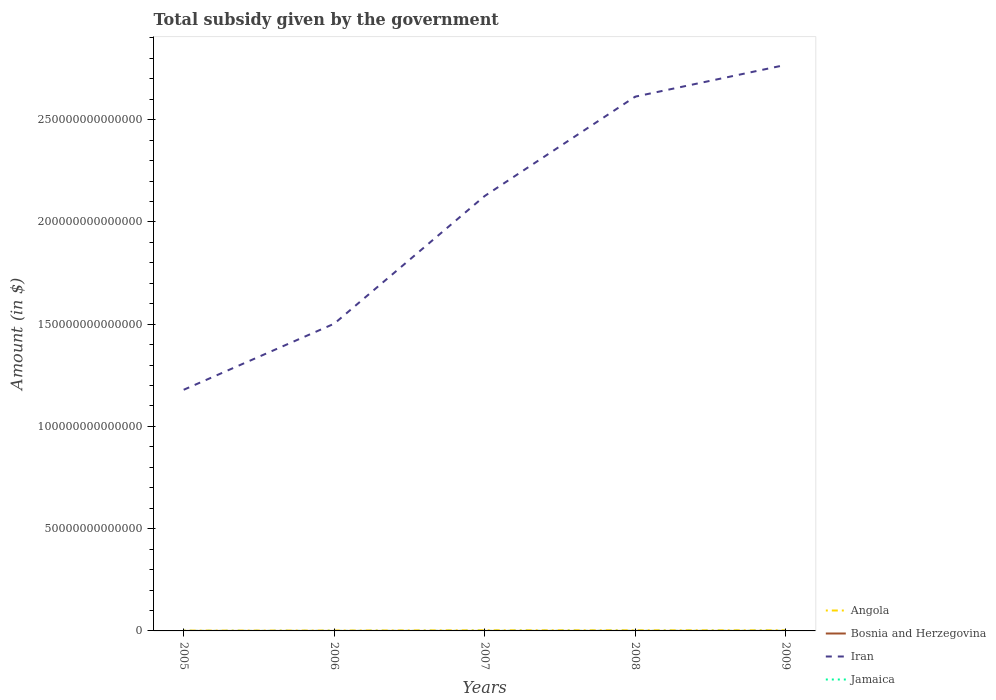Across all years, what is the maximum total revenue collected by the government in Bosnia and Herzegovina?
Your answer should be very brief. 2.42e+09. In which year was the total revenue collected by the government in Iran maximum?
Offer a very short reply. 2005. What is the total total revenue collected by the government in Bosnia and Herzegovina in the graph?
Ensure brevity in your answer.  -1.09e+09. What is the difference between the highest and the second highest total revenue collected by the government in Bosnia and Herzegovina?
Your response must be concise. 1.95e+09. What is the difference between two consecutive major ticks on the Y-axis?
Keep it short and to the point. 5.00e+13. Does the graph contain any zero values?
Give a very brief answer. No. Where does the legend appear in the graph?
Provide a short and direct response. Bottom right. How many legend labels are there?
Keep it short and to the point. 4. How are the legend labels stacked?
Your response must be concise. Vertical. What is the title of the graph?
Offer a terse response. Total subsidy given by the government. Does "Peru" appear as one of the legend labels in the graph?
Offer a very short reply. No. What is the label or title of the Y-axis?
Keep it short and to the point. Amount (in $). What is the Amount (in $) in Angola in 2005?
Your answer should be compact. 1.53e+11. What is the Amount (in $) of Bosnia and Herzegovina in 2005?
Ensure brevity in your answer.  2.42e+09. What is the Amount (in $) in Iran in 2005?
Keep it short and to the point. 1.18e+14. What is the Amount (in $) of Jamaica in 2005?
Offer a very short reply. 1.32e+1. What is the Amount (in $) of Angola in 2006?
Keep it short and to the point. 1.86e+11. What is the Amount (in $) in Bosnia and Herzegovina in 2006?
Make the answer very short. 2.77e+09. What is the Amount (in $) of Iran in 2006?
Provide a short and direct response. 1.50e+14. What is the Amount (in $) of Jamaica in 2006?
Your answer should be very brief. 1.67e+1. What is the Amount (in $) of Angola in 2007?
Your response must be concise. 2.96e+11. What is the Amount (in $) of Bosnia and Herzegovina in 2007?
Provide a succinct answer. 3.51e+09. What is the Amount (in $) in Iran in 2007?
Provide a short and direct response. 2.13e+14. What is the Amount (in $) in Jamaica in 2007?
Your response must be concise. 2.02e+1. What is the Amount (in $) of Angola in 2008?
Your response must be concise. 2.94e+11. What is the Amount (in $) of Bosnia and Herzegovina in 2008?
Your answer should be compact. 4.37e+09. What is the Amount (in $) in Iran in 2008?
Your answer should be very brief. 2.61e+14. What is the Amount (in $) of Jamaica in 2008?
Your response must be concise. 2.37e+1. What is the Amount (in $) in Angola in 2009?
Your response must be concise. 2.86e+11. What is the Amount (in $) of Bosnia and Herzegovina in 2009?
Your answer should be very brief. 4.37e+09. What is the Amount (in $) of Iran in 2009?
Make the answer very short. 2.77e+14. What is the Amount (in $) of Jamaica in 2009?
Keep it short and to the point. 2.53e+1. Across all years, what is the maximum Amount (in $) in Angola?
Ensure brevity in your answer.  2.96e+11. Across all years, what is the maximum Amount (in $) in Bosnia and Herzegovina?
Your answer should be very brief. 4.37e+09. Across all years, what is the maximum Amount (in $) in Iran?
Your answer should be very brief. 2.77e+14. Across all years, what is the maximum Amount (in $) in Jamaica?
Provide a short and direct response. 2.53e+1. Across all years, what is the minimum Amount (in $) of Angola?
Your answer should be very brief. 1.53e+11. Across all years, what is the minimum Amount (in $) of Bosnia and Herzegovina?
Ensure brevity in your answer.  2.42e+09. Across all years, what is the minimum Amount (in $) of Iran?
Provide a succinct answer. 1.18e+14. Across all years, what is the minimum Amount (in $) of Jamaica?
Your answer should be compact. 1.32e+1. What is the total Amount (in $) in Angola in the graph?
Ensure brevity in your answer.  1.21e+12. What is the total Amount (in $) in Bosnia and Herzegovina in the graph?
Ensure brevity in your answer.  1.74e+1. What is the total Amount (in $) of Iran in the graph?
Give a very brief answer. 1.02e+15. What is the total Amount (in $) of Jamaica in the graph?
Ensure brevity in your answer.  9.90e+1. What is the difference between the Amount (in $) of Angola in 2005 and that in 2006?
Offer a terse response. -3.26e+1. What is the difference between the Amount (in $) of Bosnia and Herzegovina in 2005 and that in 2006?
Offer a very short reply. -3.45e+08. What is the difference between the Amount (in $) of Iran in 2005 and that in 2006?
Offer a very short reply. -3.23e+13. What is the difference between the Amount (in $) in Jamaica in 2005 and that in 2006?
Offer a terse response. -3.44e+09. What is the difference between the Amount (in $) in Angola in 2005 and that in 2007?
Offer a very short reply. -1.43e+11. What is the difference between the Amount (in $) in Bosnia and Herzegovina in 2005 and that in 2007?
Provide a short and direct response. -1.09e+09. What is the difference between the Amount (in $) of Iran in 2005 and that in 2007?
Make the answer very short. -9.48e+13. What is the difference between the Amount (in $) in Jamaica in 2005 and that in 2007?
Ensure brevity in your answer.  -6.96e+09. What is the difference between the Amount (in $) of Angola in 2005 and that in 2008?
Ensure brevity in your answer.  -1.41e+11. What is the difference between the Amount (in $) in Bosnia and Herzegovina in 2005 and that in 2008?
Your answer should be very brief. -1.95e+09. What is the difference between the Amount (in $) of Iran in 2005 and that in 2008?
Provide a short and direct response. -1.43e+14. What is the difference between the Amount (in $) in Jamaica in 2005 and that in 2008?
Offer a terse response. -1.05e+1. What is the difference between the Amount (in $) in Angola in 2005 and that in 2009?
Your answer should be compact. -1.33e+11. What is the difference between the Amount (in $) of Bosnia and Herzegovina in 2005 and that in 2009?
Keep it short and to the point. -1.95e+09. What is the difference between the Amount (in $) in Iran in 2005 and that in 2009?
Your answer should be very brief. -1.59e+14. What is the difference between the Amount (in $) of Jamaica in 2005 and that in 2009?
Your answer should be very brief. -1.20e+1. What is the difference between the Amount (in $) in Angola in 2006 and that in 2007?
Make the answer very short. -1.11e+11. What is the difference between the Amount (in $) of Bosnia and Herzegovina in 2006 and that in 2007?
Give a very brief answer. -7.43e+08. What is the difference between the Amount (in $) of Iran in 2006 and that in 2007?
Make the answer very short. -6.24e+13. What is the difference between the Amount (in $) in Jamaica in 2006 and that in 2007?
Your answer should be compact. -3.52e+09. What is the difference between the Amount (in $) of Angola in 2006 and that in 2008?
Offer a terse response. -1.08e+11. What is the difference between the Amount (in $) of Bosnia and Herzegovina in 2006 and that in 2008?
Your answer should be compact. -1.60e+09. What is the difference between the Amount (in $) in Iran in 2006 and that in 2008?
Make the answer very short. -1.11e+14. What is the difference between the Amount (in $) of Jamaica in 2006 and that in 2008?
Your answer should be very brief. -7.02e+09. What is the difference between the Amount (in $) in Angola in 2006 and that in 2009?
Provide a succinct answer. -1.00e+11. What is the difference between the Amount (in $) of Bosnia and Herzegovina in 2006 and that in 2009?
Ensure brevity in your answer.  -1.60e+09. What is the difference between the Amount (in $) in Iran in 2006 and that in 2009?
Your answer should be compact. -1.27e+14. What is the difference between the Amount (in $) of Jamaica in 2006 and that in 2009?
Your answer should be very brief. -8.60e+09. What is the difference between the Amount (in $) of Angola in 2007 and that in 2008?
Your answer should be compact. 2.50e+09. What is the difference between the Amount (in $) of Bosnia and Herzegovina in 2007 and that in 2008?
Provide a short and direct response. -8.58e+08. What is the difference between the Amount (in $) in Iran in 2007 and that in 2008?
Provide a short and direct response. -4.86e+13. What is the difference between the Amount (in $) in Jamaica in 2007 and that in 2008?
Provide a short and direct response. -3.50e+09. What is the difference between the Amount (in $) of Angola in 2007 and that in 2009?
Offer a very short reply. 1.06e+1. What is the difference between the Amount (in $) in Bosnia and Herzegovina in 2007 and that in 2009?
Give a very brief answer. -8.59e+08. What is the difference between the Amount (in $) of Iran in 2007 and that in 2009?
Offer a very short reply. -6.41e+13. What is the difference between the Amount (in $) of Jamaica in 2007 and that in 2009?
Offer a terse response. -5.08e+09. What is the difference between the Amount (in $) of Angola in 2008 and that in 2009?
Provide a succinct answer. 8.11e+09. What is the difference between the Amount (in $) of Bosnia and Herzegovina in 2008 and that in 2009?
Make the answer very short. -8.19e+05. What is the difference between the Amount (in $) in Iran in 2008 and that in 2009?
Give a very brief answer. -1.55e+13. What is the difference between the Amount (in $) of Jamaica in 2008 and that in 2009?
Ensure brevity in your answer.  -1.58e+09. What is the difference between the Amount (in $) of Angola in 2005 and the Amount (in $) of Bosnia and Herzegovina in 2006?
Provide a succinct answer. 1.50e+11. What is the difference between the Amount (in $) of Angola in 2005 and the Amount (in $) of Iran in 2006?
Offer a very short reply. -1.50e+14. What is the difference between the Amount (in $) of Angola in 2005 and the Amount (in $) of Jamaica in 2006?
Ensure brevity in your answer.  1.36e+11. What is the difference between the Amount (in $) of Bosnia and Herzegovina in 2005 and the Amount (in $) of Iran in 2006?
Provide a short and direct response. -1.50e+14. What is the difference between the Amount (in $) in Bosnia and Herzegovina in 2005 and the Amount (in $) in Jamaica in 2006?
Make the answer very short. -1.42e+1. What is the difference between the Amount (in $) in Iran in 2005 and the Amount (in $) in Jamaica in 2006?
Your response must be concise. 1.18e+14. What is the difference between the Amount (in $) of Angola in 2005 and the Amount (in $) of Bosnia and Herzegovina in 2007?
Your response must be concise. 1.49e+11. What is the difference between the Amount (in $) in Angola in 2005 and the Amount (in $) in Iran in 2007?
Offer a very short reply. -2.13e+14. What is the difference between the Amount (in $) in Angola in 2005 and the Amount (in $) in Jamaica in 2007?
Provide a short and direct response. 1.33e+11. What is the difference between the Amount (in $) of Bosnia and Herzegovina in 2005 and the Amount (in $) of Iran in 2007?
Offer a very short reply. -2.13e+14. What is the difference between the Amount (in $) in Bosnia and Herzegovina in 2005 and the Amount (in $) in Jamaica in 2007?
Ensure brevity in your answer.  -1.78e+1. What is the difference between the Amount (in $) in Iran in 2005 and the Amount (in $) in Jamaica in 2007?
Your answer should be very brief. 1.18e+14. What is the difference between the Amount (in $) of Angola in 2005 and the Amount (in $) of Bosnia and Herzegovina in 2008?
Your answer should be compact. 1.49e+11. What is the difference between the Amount (in $) in Angola in 2005 and the Amount (in $) in Iran in 2008?
Keep it short and to the point. -2.61e+14. What is the difference between the Amount (in $) in Angola in 2005 and the Amount (in $) in Jamaica in 2008?
Provide a short and direct response. 1.29e+11. What is the difference between the Amount (in $) in Bosnia and Herzegovina in 2005 and the Amount (in $) in Iran in 2008?
Make the answer very short. -2.61e+14. What is the difference between the Amount (in $) of Bosnia and Herzegovina in 2005 and the Amount (in $) of Jamaica in 2008?
Provide a short and direct response. -2.13e+1. What is the difference between the Amount (in $) of Iran in 2005 and the Amount (in $) of Jamaica in 2008?
Your answer should be compact. 1.18e+14. What is the difference between the Amount (in $) of Angola in 2005 and the Amount (in $) of Bosnia and Herzegovina in 2009?
Keep it short and to the point. 1.49e+11. What is the difference between the Amount (in $) of Angola in 2005 and the Amount (in $) of Iran in 2009?
Keep it short and to the point. -2.77e+14. What is the difference between the Amount (in $) in Angola in 2005 and the Amount (in $) in Jamaica in 2009?
Ensure brevity in your answer.  1.28e+11. What is the difference between the Amount (in $) in Bosnia and Herzegovina in 2005 and the Amount (in $) in Iran in 2009?
Make the answer very short. -2.77e+14. What is the difference between the Amount (in $) of Bosnia and Herzegovina in 2005 and the Amount (in $) of Jamaica in 2009?
Your answer should be very brief. -2.28e+1. What is the difference between the Amount (in $) of Iran in 2005 and the Amount (in $) of Jamaica in 2009?
Offer a terse response. 1.18e+14. What is the difference between the Amount (in $) of Angola in 2006 and the Amount (in $) of Bosnia and Herzegovina in 2007?
Provide a short and direct response. 1.82e+11. What is the difference between the Amount (in $) in Angola in 2006 and the Amount (in $) in Iran in 2007?
Give a very brief answer. -2.12e+14. What is the difference between the Amount (in $) of Angola in 2006 and the Amount (in $) of Jamaica in 2007?
Offer a terse response. 1.65e+11. What is the difference between the Amount (in $) of Bosnia and Herzegovina in 2006 and the Amount (in $) of Iran in 2007?
Your answer should be very brief. -2.13e+14. What is the difference between the Amount (in $) in Bosnia and Herzegovina in 2006 and the Amount (in $) in Jamaica in 2007?
Your response must be concise. -1.74e+1. What is the difference between the Amount (in $) of Iran in 2006 and the Amount (in $) of Jamaica in 2007?
Your response must be concise. 1.50e+14. What is the difference between the Amount (in $) in Angola in 2006 and the Amount (in $) in Bosnia and Herzegovina in 2008?
Give a very brief answer. 1.81e+11. What is the difference between the Amount (in $) in Angola in 2006 and the Amount (in $) in Iran in 2008?
Offer a very short reply. -2.61e+14. What is the difference between the Amount (in $) in Angola in 2006 and the Amount (in $) in Jamaica in 2008?
Offer a very short reply. 1.62e+11. What is the difference between the Amount (in $) in Bosnia and Herzegovina in 2006 and the Amount (in $) in Iran in 2008?
Provide a short and direct response. -2.61e+14. What is the difference between the Amount (in $) in Bosnia and Herzegovina in 2006 and the Amount (in $) in Jamaica in 2008?
Ensure brevity in your answer.  -2.09e+1. What is the difference between the Amount (in $) of Iran in 2006 and the Amount (in $) of Jamaica in 2008?
Provide a succinct answer. 1.50e+14. What is the difference between the Amount (in $) in Angola in 2006 and the Amount (in $) in Bosnia and Herzegovina in 2009?
Give a very brief answer. 1.81e+11. What is the difference between the Amount (in $) of Angola in 2006 and the Amount (in $) of Iran in 2009?
Offer a terse response. -2.77e+14. What is the difference between the Amount (in $) of Angola in 2006 and the Amount (in $) of Jamaica in 2009?
Provide a short and direct response. 1.60e+11. What is the difference between the Amount (in $) of Bosnia and Herzegovina in 2006 and the Amount (in $) of Iran in 2009?
Make the answer very short. -2.77e+14. What is the difference between the Amount (in $) of Bosnia and Herzegovina in 2006 and the Amount (in $) of Jamaica in 2009?
Provide a short and direct response. -2.25e+1. What is the difference between the Amount (in $) of Iran in 2006 and the Amount (in $) of Jamaica in 2009?
Your answer should be very brief. 1.50e+14. What is the difference between the Amount (in $) in Angola in 2007 and the Amount (in $) in Bosnia and Herzegovina in 2008?
Offer a very short reply. 2.92e+11. What is the difference between the Amount (in $) of Angola in 2007 and the Amount (in $) of Iran in 2008?
Give a very brief answer. -2.61e+14. What is the difference between the Amount (in $) of Angola in 2007 and the Amount (in $) of Jamaica in 2008?
Provide a succinct answer. 2.73e+11. What is the difference between the Amount (in $) of Bosnia and Herzegovina in 2007 and the Amount (in $) of Iran in 2008?
Your answer should be compact. -2.61e+14. What is the difference between the Amount (in $) of Bosnia and Herzegovina in 2007 and the Amount (in $) of Jamaica in 2008?
Ensure brevity in your answer.  -2.02e+1. What is the difference between the Amount (in $) in Iran in 2007 and the Amount (in $) in Jamaica in 2008?
Make the answer very short. 2.13e+14. What is the difference between the Amount (in $) in Angola in 2007 and the Amount (in $) in Bosnia and Herzegovina in 2009?
Make the answer very short. 2.92e+11. What is the difference between the Amount (in $) in Angola in 2007 and the Amount (in $) in Iran in 2009?
Offer a terse response. -2.77e+14. What is the difference between the Amount (in $) of Angola in 2007 and the Amount (in $) of Jamaica in 2009?
Give a very brief answer. 2.71e+11. What is the difference between the Amount (in $) of Bosnia and Herzegovina in 2007 and the Amount (in $) of Iran in 2009?
Your response must be concise. -2.77e+14. What is the difference between the Amount (in $) in Bosnia and Herzegovina in 2007 and the Amount (in $) in Jamaica in 2009?
Your response must be concise. -2.17e+1. What is the difference between the Amount (in $) of Iran in 2007 and the Amount (in $) of Jamaica in 2009?
Offer a very short reply. 2.13e+14. What is the difference between the Amount (in $) of Angola in 2008 and the Amount (in $) of Bosnia and Herzegovina in 2009?
Make the answer very short. 2.90e+11. What is the difference between the Amount (in $) of Angola in 2008 and the Amount (in $) of Iran in 2009?
Give a very brief answer. -2.77e+14. What is the difference between the Amount (in $) of Angola in 2008 and the Amount (in $) of Jamaica in 2009?
Provide a short and direct response. 2.69e+11. What is the difference between the Amount (in $) of Bosnia and Herzegovina in 2008 and the Amount (in $) of Iran in 2009?
Give a very brief answer. -2.77e+14. What is the difference between the Amount (in $) of Bosnia and Herzegovina in 2008 and the Amount (in $) of Jamaica in 2009?
Provide a short and direct response. -2.09e+1. What is the difference between the Amount (in $) of Iran in 2008 and the Amount (in $) of Jamaica in 2009?
Offer a terse response. 2.61e+14. What is the average Amount (in $) in Angola per year?
Offer a very short reply. 2.43e+11. What is the average Amount (in $) in Bosnia and Herzegovina per year?
Provide a succinct answer. 3.49e+09. What is the average Amount (in $) in Iran per year?
Offer a very short reply. 2.04e+14. What is the average Amount (in $) in Jamaica per year?
Offer a terse response. 1.98e+1. In the year 2005, what is the difference between the Amount (in $) of Angola and Amount (in $) of Bosnia and Herzegovina?
Keep it short and to the point. 1.51e+11. In the year 2005, what is the difference between the Amount (in $) of Angola and Amount (in $) of Iran?
Offer a very short reply. -1.18e+14. In the year 2005, what is the difference between the Amount (in $) of Angola and Amount (in $) of Jamaica?
Your answer should be very brief. 1.40e+11. In the year 2005, what is the difference between the Amount (in $) of Bosnia and Herzegovina and Amount (in $) of Iran?
Ensure brevity in your answer.  -1.18e+14. In the year 2005, what is the difference between the Amount (in $) in Bosnia and Herzegovina and Amount (in $) in Jamaica?
Your response must be concise. -1.08e+1. In the year 2005, what is the difference between the Amount (in $) of Iran and Amount (in $) of Jamaica?
Offer a very short reply. 1.18e+14. In the year 2006, what is the difference between the Amount (in $) in Angola and Amount (in $) in Bosnia and Herzegovina?
Keep it short and to the point. 1.83e+11. In the year 2006, what is the difference between the Amount (in $) of Angola and Amount (in $) of Iran?
Your answer should be very brief. -1.50e+14. In the year 2006, what is the difference between the Amount (in $) of Angola and Amount (in $) of Jamaica?
Your answer should be very brief. 1.69e+11. In the year 2006, what is the difference between the Amount (in $) of Bosnia and Herzegovina and Amount (in $) of Iran?
Provide a short and direct response. -1.50e+14. In the year 2006, what is the difference between the Amount (in $) of Bosnia and Herzegovina and Amount (in $) of Jamaica?
Keep it short and to the point. -1.39e+1. In the year 2006, what is the difference between the Amount (in $) of Iran and Amount (in $) of Jamaica?
Your answer should be very brief. 1.50e+14. In the year 2007, what is the difference between the Amount (in $) of Angola and Amount (in $) of Bosnia and Herzegovina?
Give a very brief answer. 2.93e+11. In the year 2007, what is the difference between the Amount (in $) of Angola and Amount (in $) of Iran?
Provide a short and direct response. -2.12e+14. In the year 2007, what is the difference between the Amount (in $) of Angola and Amount (in $) of Jamaica?
Keep it short and to the point. 2.76e+11. In the year 2007, what is the difference between the Amount (in $) of Bosnia and Herzegovina and Amount (in $) of Iran?
Offer a very short reply. -2.13e+14. In the year 2007, what is the difference between the Amount (in $) in Bosnia and Herzegovina and Amount (in $) in Jamaica?
Your answer should be very brief. -1.67e+1. In the year 2007, what is the difference between the Amount (in $) of Iran and Amount (in $) of Jamaica?
Provide a short and direct response. 2.13e+14. In the year 2008, what is the difference between the Amount (in $) of Angola and Amount (in $) of Bosnia and Herzegovina?
Offer a terse response. 2.90e+11. In the year 2008, what is the difference between the Amount (in $) in Angola and Amount (in $) in Iran?
Keep it short and to the point. -2.61e+14. In the year 2008, what is the difference between the Amount (in $) in Angola and Amount (in $) in Jamaica?
Provide a short and direct response. 2.70e+11. In the year 2008, what is the difference between the Amount (in $) of Bosnia and Herzegovina and Amount (in $) of Iran?
Offer a terse response. -2.61e+14. In the year 2008, what is the difference between the Amount (in $) in Bosnia and Herzegovina and Amount (in $) in Jamaica?
Your answer should be very brief. -1.93e+1. In the year 2008, what is the difference between the Amount (in $) of Iran and Amount (in $) of Jamaica?
Offer a terse response. 2.61e+14. In the year 2009, what is the difference between the Amount (in $) in Angola and Amount (in $) in Bosnia and Herzegovina?
Give a very brief answer. 2.81e+11. In the year 2009, what is the difference between the Amount (in $) of Angola and Amount (in $) of Iran?
Your response must be concise. -2.77e+14. In the year 2009, what is the difference between the Amount (in $) in Angola and Amount (in $) in Jamaica?
Offer a terse response. 2.61e+11. In the year 2009, what is the difference between the Amount (in $) in Bosnia and Herzegovina and Amount (in $) in Iran?
Ensure brevity in your answer.  -2.77e+14. In the year 2009, what is the difference between the Amount (in $) of Bosnia and Herzegovina and Amount (in $) of Jamaica?
Provide a succinct answer. -2.09e+1. In the year 2009, what is the difference between the Amount (in $) of Iran and Amount (in $) of Jamaica?
Provide a succinct answer. 2.77e+14. What is the ratio of the Amount (in $) in Angola in 2005 to that in 2006?
Provide a succinct answer. 0.82. What is the ratio of the Amount (in $) in Bosnia and Herzegovina in 2005 to that in 2006?
Provide a succinct answer. 0.88. What is the ratio of the Amount (in $) in Iran in 2005 to that in 2006?
Keep it short and to the point. 0.78. What is the ratio of the Amount (in $) of Jamaica in 2005 to that in 2006?
Offer a very short reply. 0.79. What is the ratio of the Amount (in $) of Angola in 2005 to that in 2007?
Your answer should be very brief. 0.52. What is the ratio of the Amount (in $) in Bosnia and Herzegovina in 2005 to that in 2007?
Ensure brevity in your answer.  0.69. What is the ratio of the Amount (in $) of Iran in 2005 to that in 2007?
Your answer should be compact. 0.55. What is the ratio of the Amount (in $) of Jamaica in 2005 to that in 2007?
Make the answer very short. 0.65. What is the ratio of the Amount (in $) in Angola in 2005 to that in 2008?
Your answer should be compact. 0.52. What is the ratio of the Amount (in $) of Bosnia and Herzegovina in 2005 to that in 2008?
Provide a succinct answer. 0.55. What is the ratio of the Amount (in $) of Iran in 2005 to that in 2008?
Ensure brevity in your answer.  0.45. What is the ratio of the Amount (in $) of Jamaica in 2005 to that in 2008?
Offer a terse response. 0.56. What is the ratio of the Amount (in $) of Angola in 2005 to that in 2009?
Your response must be concise. 0.54. What is the ratio of the Amount (in $) in Bosnia and Herzegovina in 2005 to that in 2009?
Offer a very short reply. 0.55. What is the ratio of the Amount (in $) in Iran in 2005 to that in 2009?
Provide a succinct answer. 0.43. What is the ratio of the Amount (in $) of Jamaica in 2005 to that in 2009?
Offer a terse response. 0.52. What is the ratio of the Amount (in $) in Angola in 2006 to that in 2007?
Make the answer very short. 0.63. What is the ratio of the Amount (in $) of Bosnia and Herzegovina in 2006 to that in 2007?
Your response must be concise. 0.79. What is the ratio of the Amount (in $) in Iran in 2006 to that in 2007?
Keep it short and to the point. 0.71. What is the ratio of the Amount (in $) of Jamaica in 2006 to that in 2007?
Provide a succinct answer. 0.83. What is the ratio of the Amount (in $) of Angola in 2006 to that in 2008?
Make the answer very short. 0.63. What is the ratio of the Amount (in $) of Bosnia and Herzegovina in 2006 to that in 2008?
Provide a short and direct response. 0.63. What is the ratio of the Amount (in $) in Iran in 2006 to that in 2008?
Provide a short and direct response. 0.57. What is the ratio of the Amount (in $) in Jamaica in 2006 to that in 2008?
Make the answer very short. 0.7. What is the ratio of the Amount (in $) in Angola in 2006 to that in 2009?
Ensure brevity in your answer.  0.65. What is the ratio of the Amount (in $) in Bosnia and Herzegovina in 2006 to that in 2009?
Your answer should be compact. 0.63. What is the ratio of the Amount (in $) of Iran in 2006 to that in 2009?
Your answer should be very brief. 0.54. What is the ratio of the Amount (in $) of Jamaica in 2006 to that in 2009?
Provide a short and direct response. 0.66. What is the ratio of the Amount (in $) of Angola in 2007 to that in 2008?
Ensure brevity in your answer.  1.01. What is the ratio of the Amount (in $) of Bosnia and Herzegovina in 2007 to that in 2008?
Make the answer very short. 0.8. What is the ratio of the Amount (in $) of Iran in 2007 to that in 2008?
Keep it short and to the point. 0.81. What is the ratio of the Amount (in $) in Jamaica in 2007 to that in 2008?
Your answer should be very brief. 0.85. What is the ratio of the Amount (in $) in Angola in 2007 to that in 2009?
Your answer should be compact. 1.04. What is the ratio of the Amount (in $) in Bosnia and Herzegovina in 2007 to that in 2009?
Your answer should be very brief. 0.8. What is the ratio of the Amount (in $) in Iran in 2007 to that in 2009?
Offer a terse response. 0.77. What is the ratio of the Amount (in $) of Jamaica in 2007 to that in 2009?
Provide a short and direct response. 0.8. What is the ratio of the Amount (in $) in Angola in 2008 to that in 2009?
Your response must be concise. 1.03. What is the ratio of the Amount (in $) of Bosnia and Herzegovina in 2008 to that in 2009?
Offer a very short reply. 1. What is the ratio of the Amount (in $) in Iran in 2008 to that in 2009?
Give a very brief answer. 0.94. What is the ratio of the Amount (in $) of Jamaica in 2008 to that in 2009?
Ensure brevity in your answer.  0.94. What is the difference between the highest and the second highest Amount (in $) of Angola?
Ensure brevity in your answer.  2.50e+09. What is the difference between the highest and the second highest Amount (in $) in Bosnia and Herzegovina?
Provide a short and direct response. 8.19e+05. What is the difference between the highest and the second highest Amount (in $) of Iran?
Give a very brief answer. 1.55e+13. What is the difference between the highest and the second highest Amount (in $) in Jamaica?
Keep it short and to the point. 1.58e+09. What is the difference between the highest and the lowest Amount (in $) in Angola?
Provide a short and direct response. 1.43e+11. What is the difference between the highest and the lowest Amount (in $) in Bosnia and Herzegovina?
Provide a short and direct response. 1.95e+09. What is the difference between the highest and the lowest Amount (in $) of Iran?
Provide a succinct answer. 1.59e+14. What is the difference between the highest and the lowest Amount (in $) in Jamaica?
Ensure brevity in your answer.  1.20e+1. 